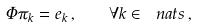<formula> <loc_0><loc_0><loc_500><loc_500>\Phi \pi _ { k } = e _ { k } \, , \quad \forall k \in \ n a t s \, ,</formula> 